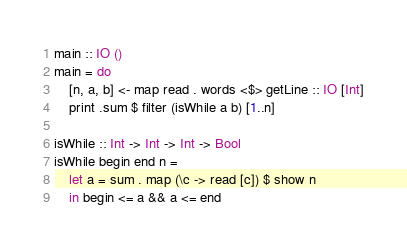<code> <loc_0><loc_0><loc_500><loc_500><_Haskell_>main :: IO ()
main = do 
    [n, a, b] <- map read . words <$> getLine :: IO [Int]
    print .sum $ filter (isWhile a b) [1..n]

isWhile :: Int -> Int -> Int -> Bool
isWhile begin end n =  
    let a = sum . map (\c -> read [c]) $ show n
    in begin <= a && a <= end</code> 